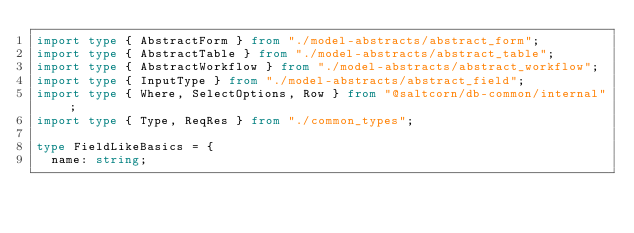Convert code to text. <code><loc_0><loc_0><loc_500><loc_500><_TypeScript_>import type { AbstractForm } from "./model-abstracts/abstract_form";
import type { AbstractTable } from "./model-abstracts/abstract_table";
import type { AbstractWorkflow } from "./model-abstracts/abstract_workflow";
import type { InputType } from "./model-abstracts/abstract_field";
import type { Where, SelectOptions, Row } from "@saltcorn/db-common/internal";
import type { Type, ReqRes } from "./common_types";

type FieldLikeBasics = {
  name: string;</code> 